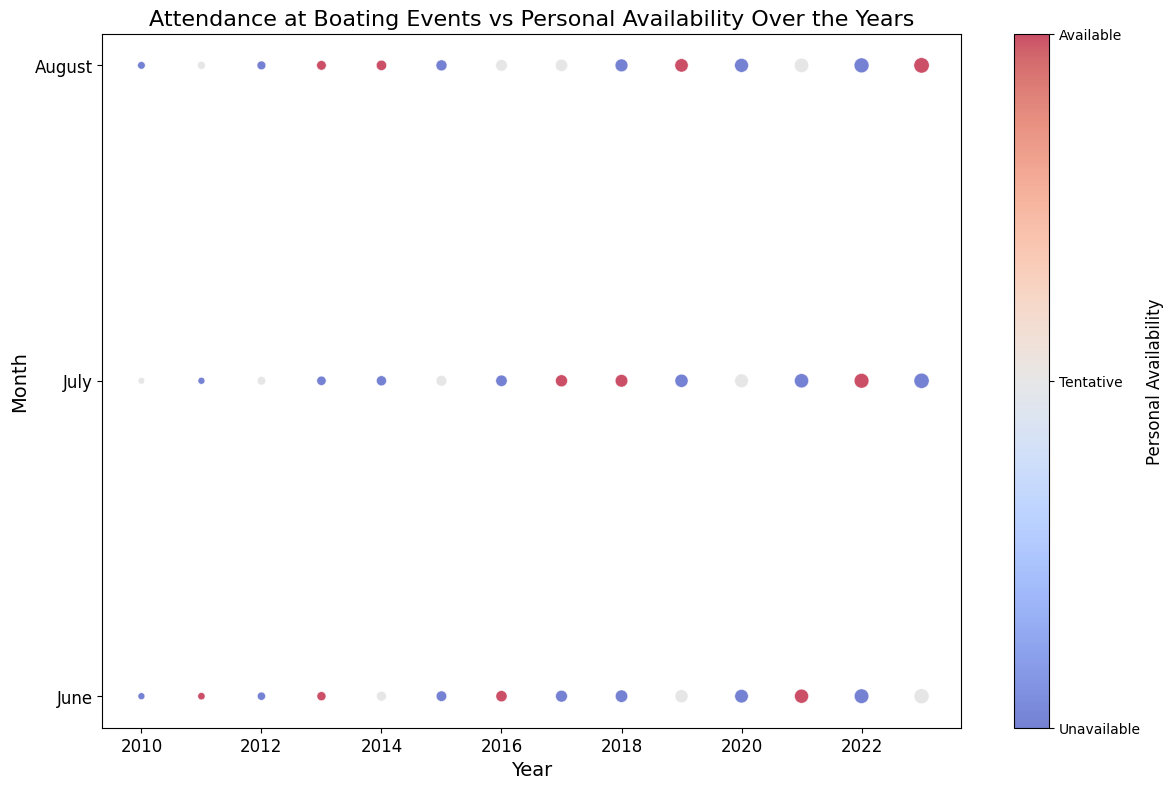What year and month had the highest attendance? To find the highest attendance, we look for the data point with the largest marker size. The highest value appears in the year 2023, month August.
Answer: 2023 August During which months over the years were you mostly unavailable? We need to look for data points with negative availability (colored red) across different years. June, August, and at some of the July events showed this pattern.
Answer: June, August, some July Which year had the most consistent personal availability? We need to identify the year where personal availability values are either consistently available (positive, blue) or unavailable (negative, red) without fluctuations. The year 2020 shows consistent unavailable statuses.
Answer: 2020 Compare attendance in June of 2013 to June of 2017. Which was higher? We compare the marker sizes for June 2013 and June 2017. June 2017 has a larger marker size than June 2013.
Answer: 2017 What's the average attendance in the months you were available? We calculate the average of the attendance values where personal availability is positive (blue). Available months (blue) are June 2011 (55), June 2013 (85), August 2013 (95), August 2014 (110), June 2016 (130), July 2017 (150), July 2018 (165), August 2019 (185), June 2021 (205), July 2022 (225), and August 2023 (245). The average is (55 + 85 + 95 + 110 + 130 + 150 + 165 + 185 + 205 + 225 + 245) / 11 = 150.
Answer: 150 Which year had the lowest personal availability on average across all months? We average the personal availability values for each year: for 2010 (-1, 0, -1), 2011 (1, -1, 0), 2012 (-1, 0, -1), 2013 (1, -1, 1), 2014 (0, -1, 1), 2015 (-1, 0, -1), 2016 (1, -1, 0), 2017 (-1, 1, 0), 2018 (-1, 1, -1), 2019 (0, -1, 1), 2020 (-1, 0, -1), 2021 (1, -1, 0), 2022 (-1, 1, -1), 2023 (0, -1, 1). The lowest average is obtained by summing and averaging these values. 2010 has the lowest average personal availability of -1 on average.
Answer: 2010 What is the change in attendance from July 2015 to July 2016? We find the attendance values for July 2015 and July 2016 and calculate their difference. Attendance in July 2015 was 120, and in July 2016 was 135. The change is 135 - 120 = 15.
Answer: 15 Which months show a pattern of increasing attendance? We observe the marker sizes across months and years; both June and August exhibit a trend of increasing attendance over the years.
Answer: June, August 